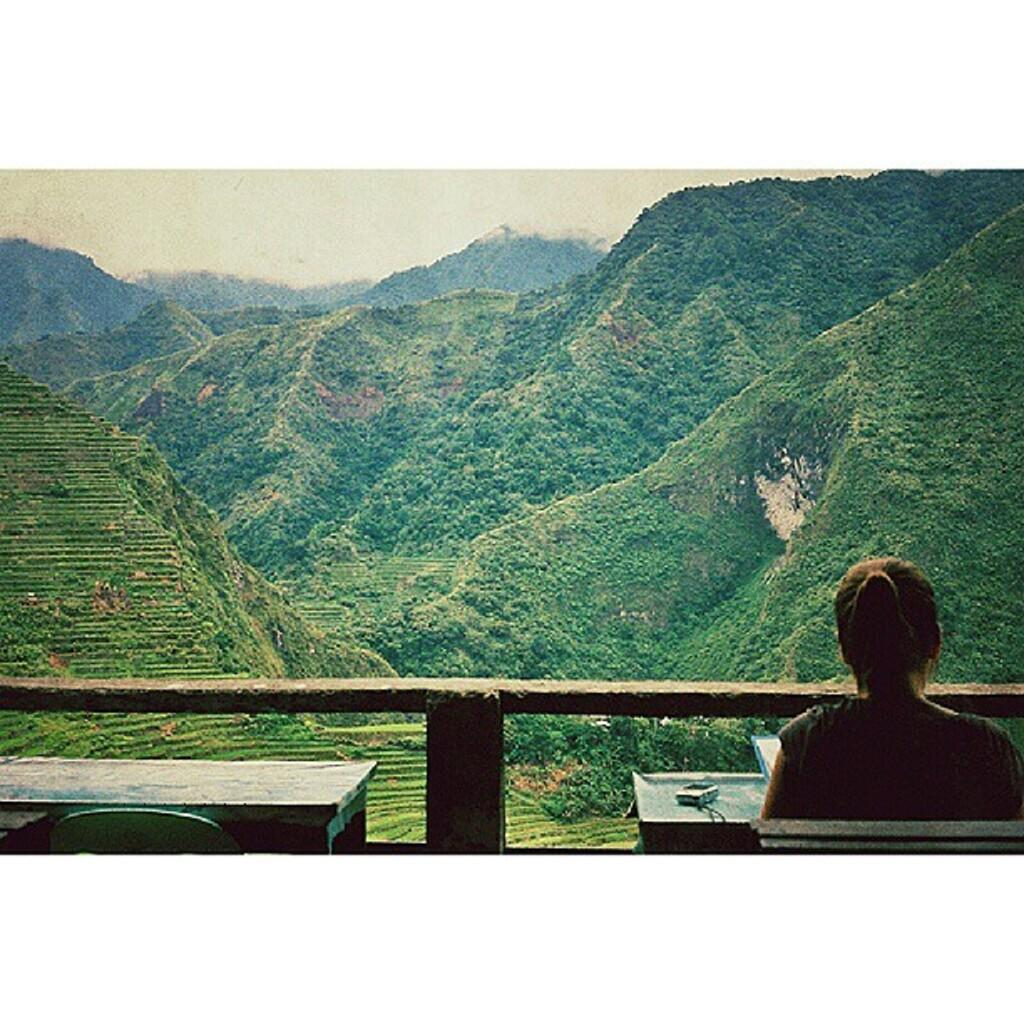What is the woman in the image doing? The woman is sitting on a chair in the image. What object can be seen in the woman's hand? There is a phone in the image. What piece of furniture is present in the image? There is a table in the image. What can be seen in the distance in the image? Mountains are visible in the background of the image. What type of harmony is the woman playing on the table in the image? There is no musical instrument or harmony present in the image; the woman is holding a phone. 